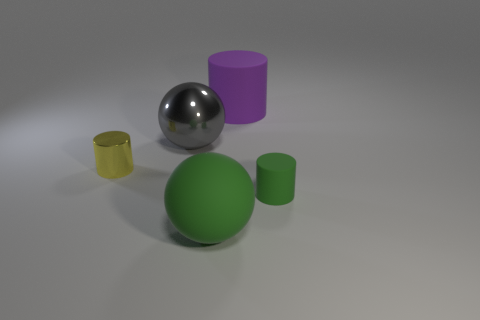What is the small yellow cylinder made of?
Your answer should be compact. Metal. What number of other things are the same shape as the yellow thing?
Provide a succinct answer. 2. How big is the purple matte thing?
Give a very brief answer. Large. There is a thing that is both to the left of the big green rubber sphere and on the right side of the small shiny object; what size is it?
Make the answer very short. Large. What is the shape of the big thing in front of the small shiny thing?
Provide a succinct answer. Sphere. Do the yellow thing and the cylinder right of the large purple cylinder have the same material?
Offer a very short reply. No. Is the shape of the big purple rubber object the same as the tiny yellow thing?
Offer a very short reply. Yes. What material is the yellow thing that is the same shape as the big purple thing?
Provide a short and direct response. Metal. There is a matte object that is in front of the small yellow metallic object and right of the big green thing; what is its color?
Ensure brevity in your answer.  Green. What is the color of the big cylinder?
Keep it short and to the point. Purple. 